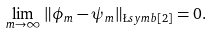<formula> <loc_0><loc_0><loc_500><loc_500>\lim _ { m \to \infty } \| \phi _ { m } - \psi _ { m } \| _ { \L s y m b [ 2 ] } = 0 .</formula> 